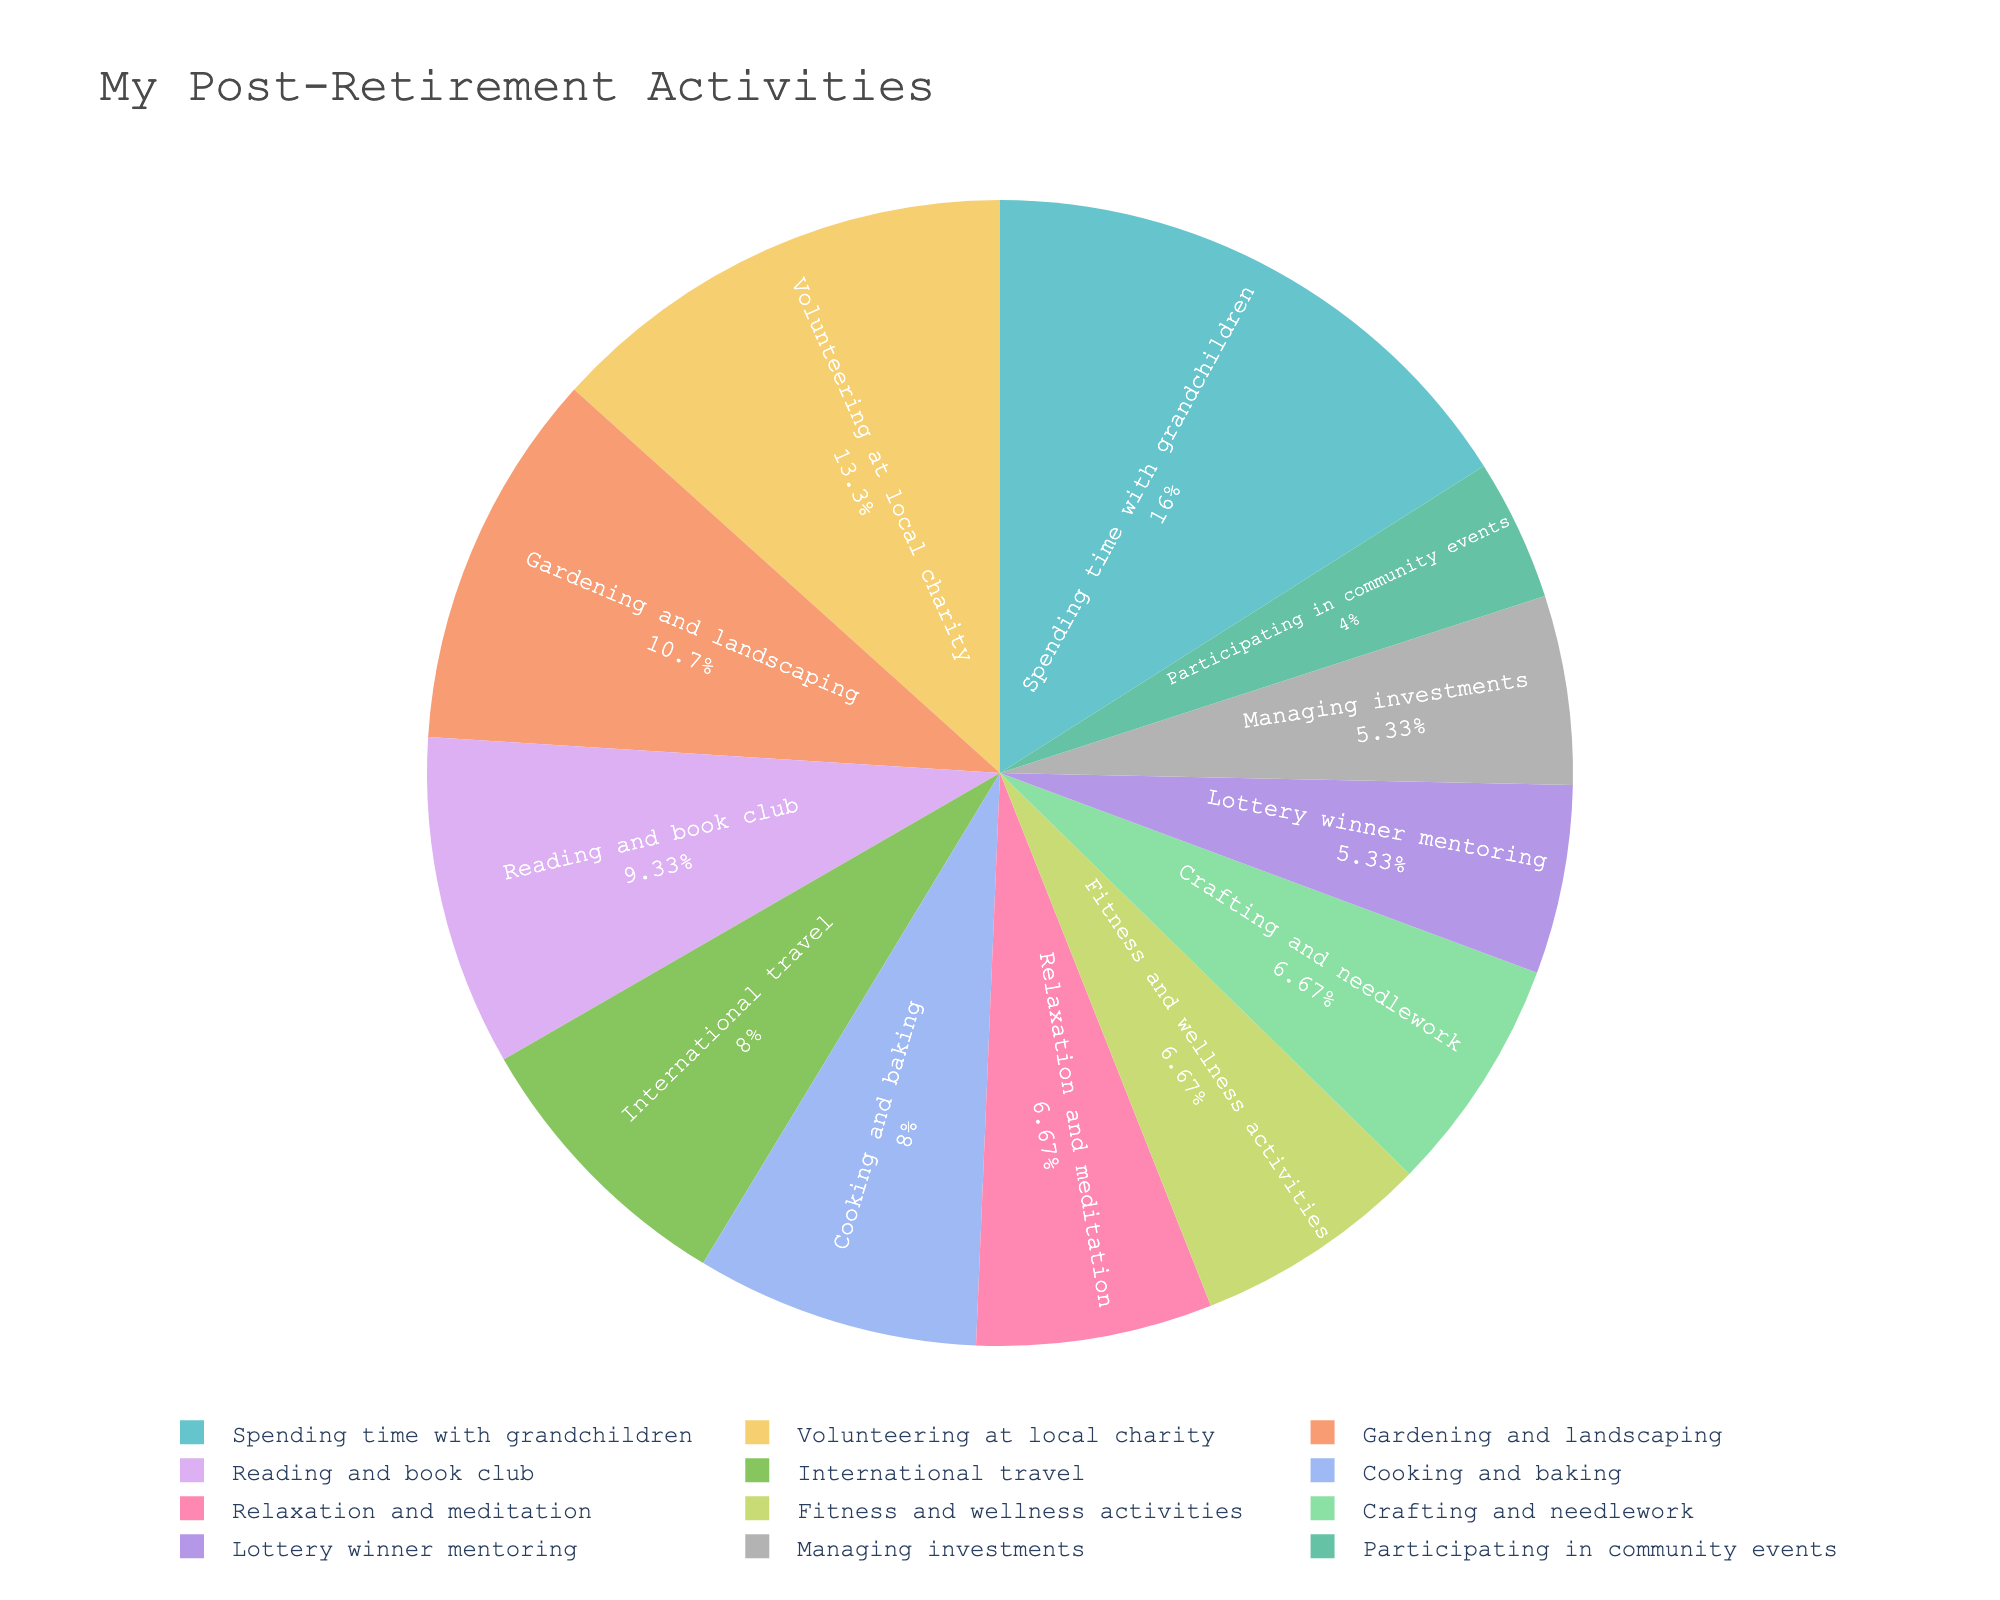what activity takes up the most time per week? The activity with the largest section of the pie chart will represent the one that takes up the most time per week. Look for the label with the highest percentage or the largest slice.
Answer: Spending time with grandchildren what activity is spent on the least per week? The activity with the smallest section of the pie chart represents the one with the least time spent per week. Look for the label with the lowest percentage or the smallest slice.
Answer: Participating in community events how many total hours per week are spent on relaxation and fitness activities together? Locate the segments for relaxation and meditation, and fitness and wellness activities in the pie chart. Sum the hours per week for these activities: 5 (relaxation and meditation) + 5 (fitness and wellness activities) = 10 hours.
Answer: 10 hours which takes up more time, cooking and baking, or international travel? Find the segments for cooking and baking, and international travel in the pie chart. Compare their sizes or percentages. Cooking and baking is 6 hours per week, and international travel is 6 hours per week.
Answer: Equal has more time spent, volunteering, or managing investments? Identify the segments for volunteering at the local charity and managing investments. Compare their sizes or percentages.  Volunteering at local charity is 10 hours per week, and managing investments is 4 hours per week, so volunteering takes up more time.
Answer: Volunteering at local charity what percentage of time is spent on gardening and landscaping, and reading and book club combined? Find the segments for gardening and landscaping, and reading and book club. Add their hours per week: 8 (gardening and landscaping) + 7 (reading and book club) = 15 hours. Then divide by the total number of hours and multiply by 100 to get the percentage. Total hours across all activities = 75; (15 / 75) * 100 = 20%.
Answer: 20% what is the ratio of hours spent on spending time with grandchildren to volunteering at the local charity? Find the segments for spending time with grandchildren and volunteering at the local charity. Ratio is the number of hours spent on spending time with grandchildren (12 hours) to volunteering at the local charity (10 hours), i.e., 12:10 or simplified form 6:5.
Answer: 6:5 which category takes up a larger portion: community events or lottery winner mentoring? Find the segments for participating in community events and lottery winner mentoring. Compare their sizes or percentages. Participating in community events is 3 hours per week, lottery winner mentoring is 4 hours per week. Lottery winner mentoring takes up a larger portion.
Answer: Lottery winner mentoring what is the combined percentage of time spent on fitness and wellness activities and crafting and needlework? Find the segments for fitness and wellness activities and crafting and needlework. Add their hours per week: 5 (fitness and wellness activities) + 5 (crafting and needlework) = 10 hours. Total hours across all activities = 75; (10 / 75) * 100 = 13.33%.
Answer: 13.33% 